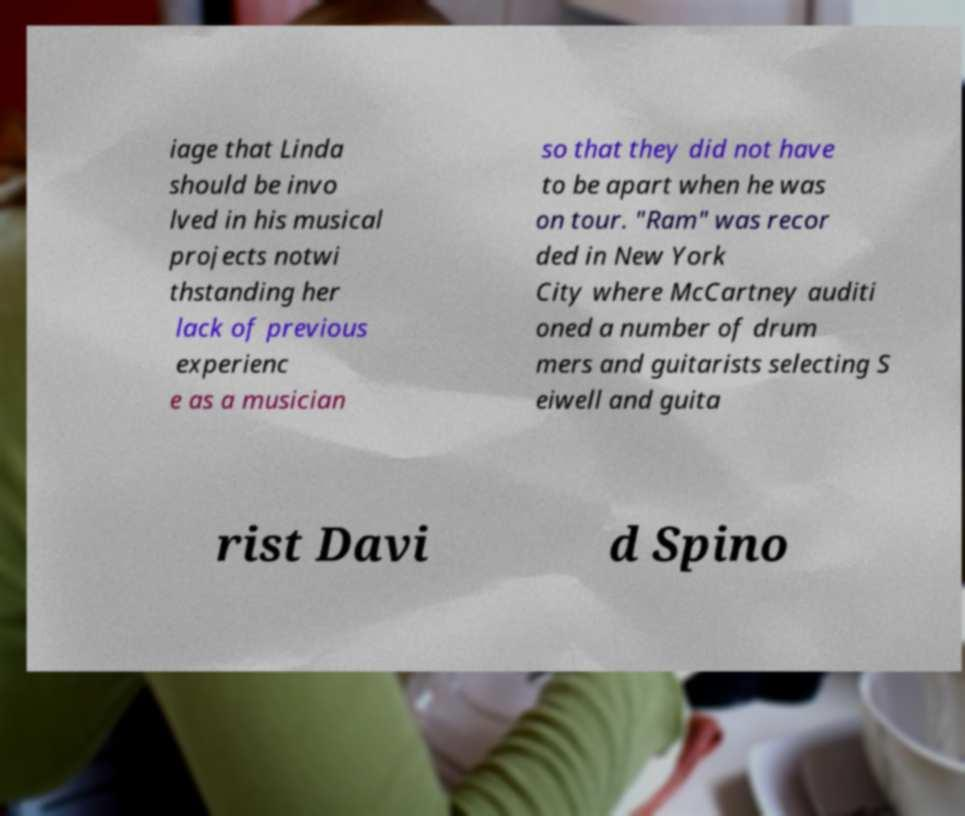Please identify and transcribe the text found in this image. iage that Linda should be invo lved in his musical projects notwi thstanding her lack of previous experienc e as a musician so that they did not have to be apart when he was on tour. "Ram" was recor ded in New York City where McCartney auditi oned a number of drum mers and guitarists selecting S eiwell and guita rist Davi d Spino 